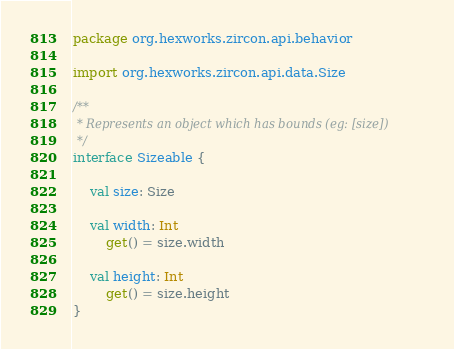<code> <loc_0><loc_0><loc_500><loc_500><_Kotlin_>package org.hexworks.zircon.api.behavior

import org.hexworks.zircon.api.data.Size

/**
 * Represents an object which has bounds (eg: [size])
 */
interface Sizeable {

    val size: Size

    val width: Int
        get() = size.width

    val height: Int
        get() = size.height
}
</code> 